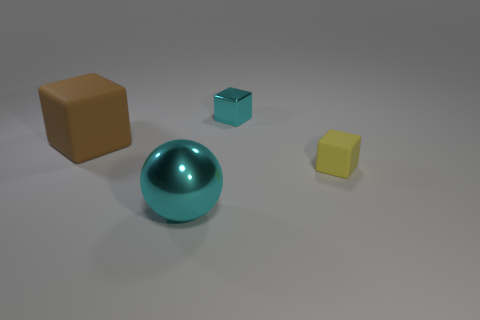Add 4 big blue cylinders. How many objects exist? 8 Subtract all balls. How many objects are left? 3 Subtract all small brown rubber cylinders. Subtract all tiny matte objects. How many objects are left? 3 Add 4 small yellow rubber cubes. How many small yellow rubber cubes are left? 5 Add 2 small rubber cubes. How many small rubber cubes exist? 3 Subtract 0 gray cylinders. How many objects are left? 4 